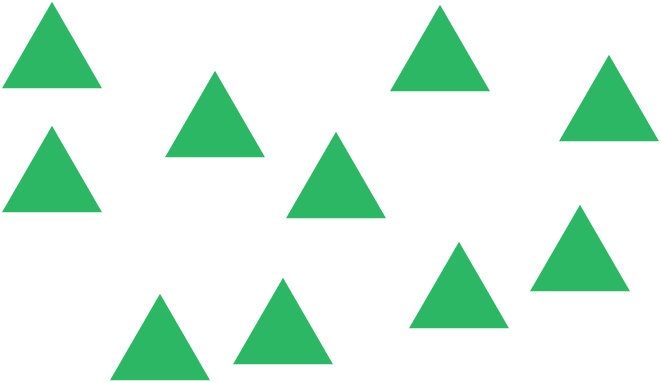Could these triangles be arranged to form another shape? Yes, the triangles in this image could potentially be arranged to form a variety of different shapes. For instance, you could arrange six triangles to form a hexagon. This kind of puzzle-like activity can be both engaging and stimulating for spatial reasoning skills. What kind of hexagon would that be? If you arranged six of these equilateral triangles with their edges aligned, you would get a regular hexagon. A regular hexagon is a six-sided shape where all sides and angles are equal, making it highly symmetrical and uniform. 